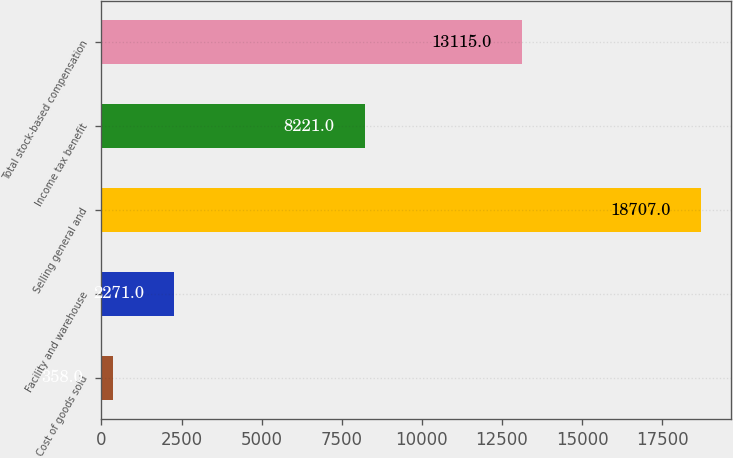Convert chart. <chart><loc_0><loc_0><loc_500><loc_500><bar_chart><fcel>Cost of goods sold<fcel>Facility and warehouse<fcel>Selling general and<fcel>Income tax benefit<fcel>Total stock-based compensation<nl><fcel>358<fcel>2271<fcel>18707<fcel>8221<fcel>13115<nl></chart> 